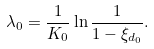Convert formula to latex. <formula><loc_0><loc_0><loc_500><loc_500>\lambda _ { 0 } = \frac { 1 } { K _ { 0 } } \ln \frac { 1 } { 1 - \xi _ { d _ { 0 } } } .</formula> 